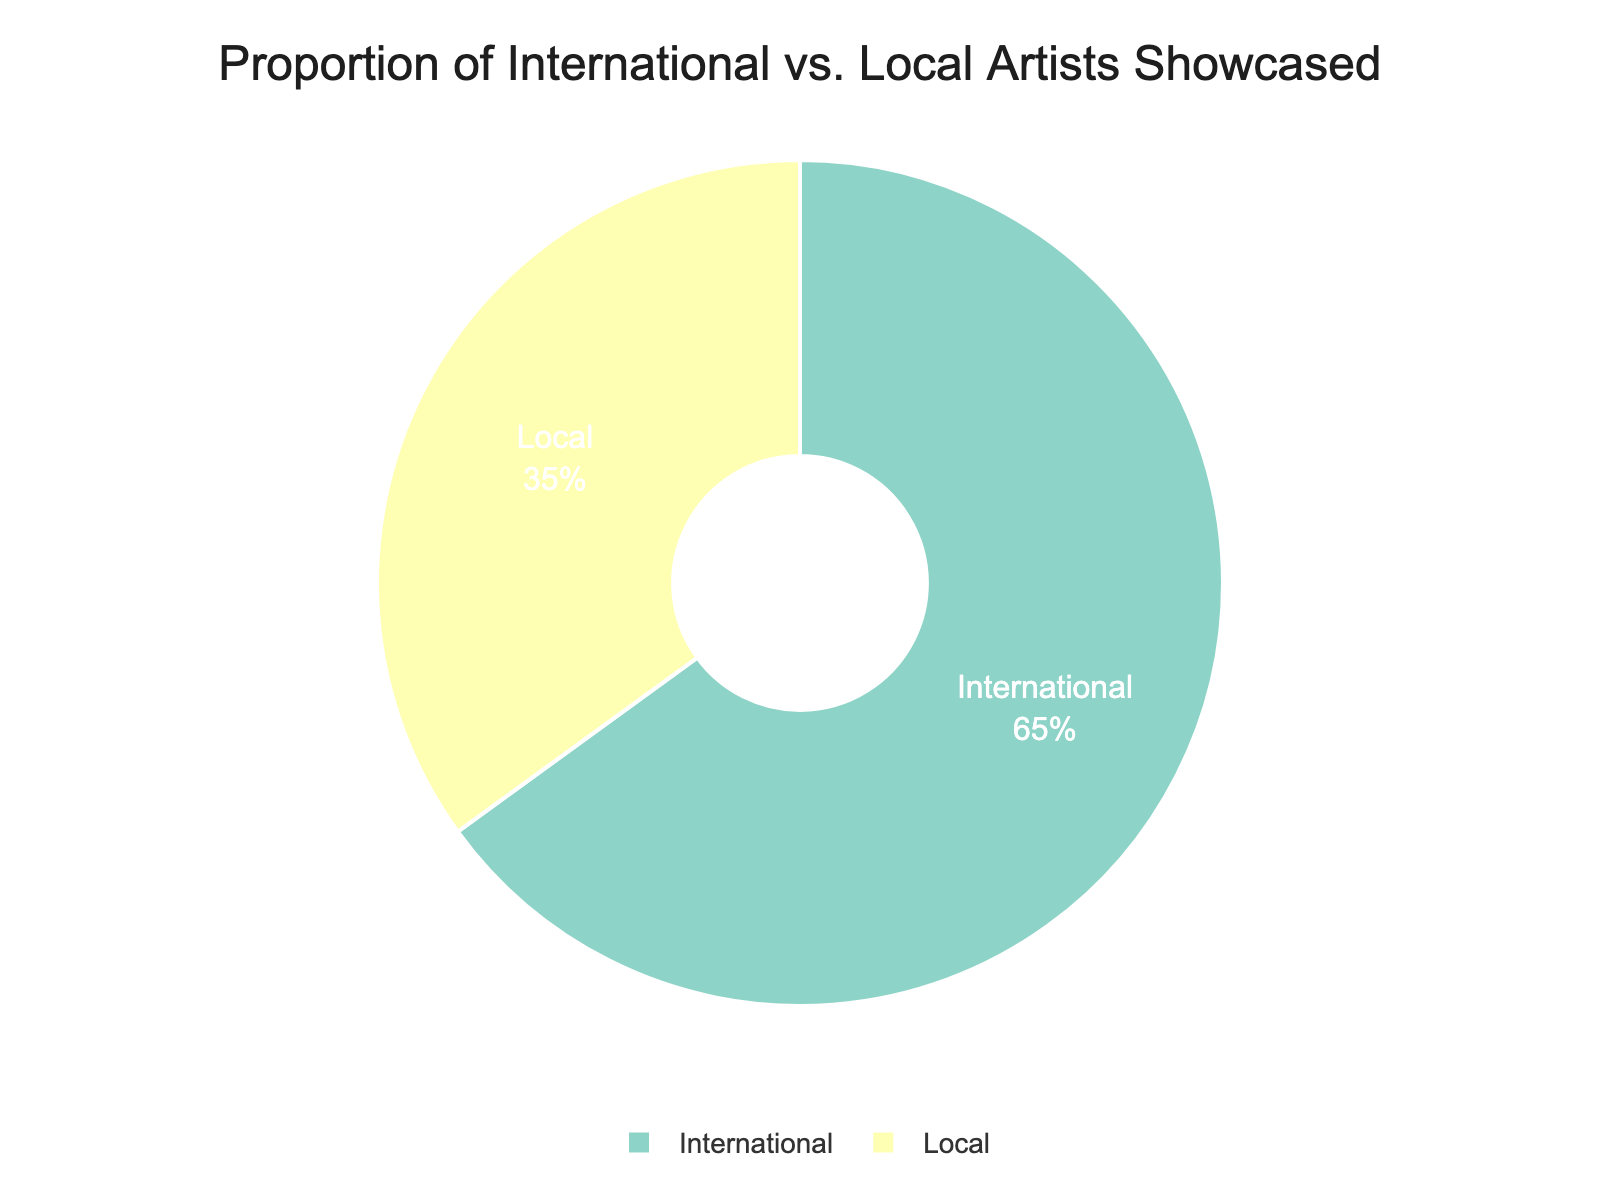What's the proportion of international artists showcased? The figure shows a pie chart with two categories: International and Local, with the percentage values displayed inside the chart. The proportion of international artists is indicated in the chart.
Answer: 65% What's the proportion of local artists showcased? The pie chart displays the percentage values for both International and Local categories. The proportion of local artists is shown directly on the chart.
Answer: 35% How much greater is the proportion of international artists compared to local artists? The chart shows the proportion of international artists as 65% and local artists as 35%. Subtracting the local proportion from the international proportion gives 65% - 35% = 30%.
Answer: 30% What percentage of the artists showcased are local if the proportion of international artists is reduced by half? If the proportion of international artists is reduced by half, it becomes 65% / 2 = 32.5%. The total must always add up to 100%, so the new proportion of local artists will be 100% - 32.5% = 67.5%.
Answer: 67.5% Is the proportion of international artists more than double that of local artists? The pie chart shows that the proportion of international artists is 65% and local artists is 35%. Double the proportion of local artists is 35% * 2 = 70%. Since 65% is less than 70%, the proportion of international artists is not more than double that of local artists.
Answer: No What is the difference between the proportions of international and local artists showcased? The difference is found by subtracting the proportion of local artists from the proportion of international artists: 65% - 35% = 30%.
Answer: 30% What would the percentage be for each category if local artists' proportion increased by 10% while maintaining the total at 100%? Increasing local artists' proportion by 10% changes it from 35% to 45%. To maintain the total at 100%, subtract 10% from the international artists' proportion: 65% - 10% = 55%. So the new percentages would be 55% for international and 45% for local artists.
Answer: International: 55%, Local: 45% Describe the colors used for each category in the pie chart. The visual attributes of the chart show that the category of International artists is represented by one color, and Local artists are represented by a different color from the qualitative color sequence used.
Answer: Different colors 